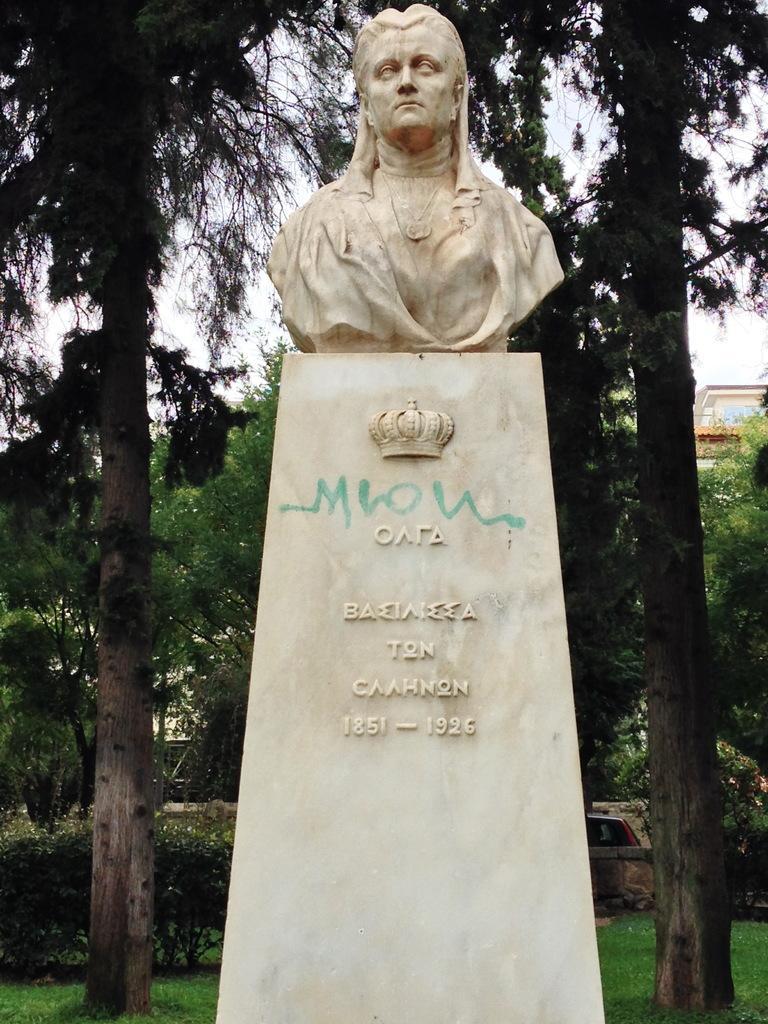Please provide a concise description of this image. In this picture we can see a sculpture on a pillar. There is some text and carving of a crown. Some grass is visible on the ground. There are a few trees, vehicle and a building is visible in the background. 